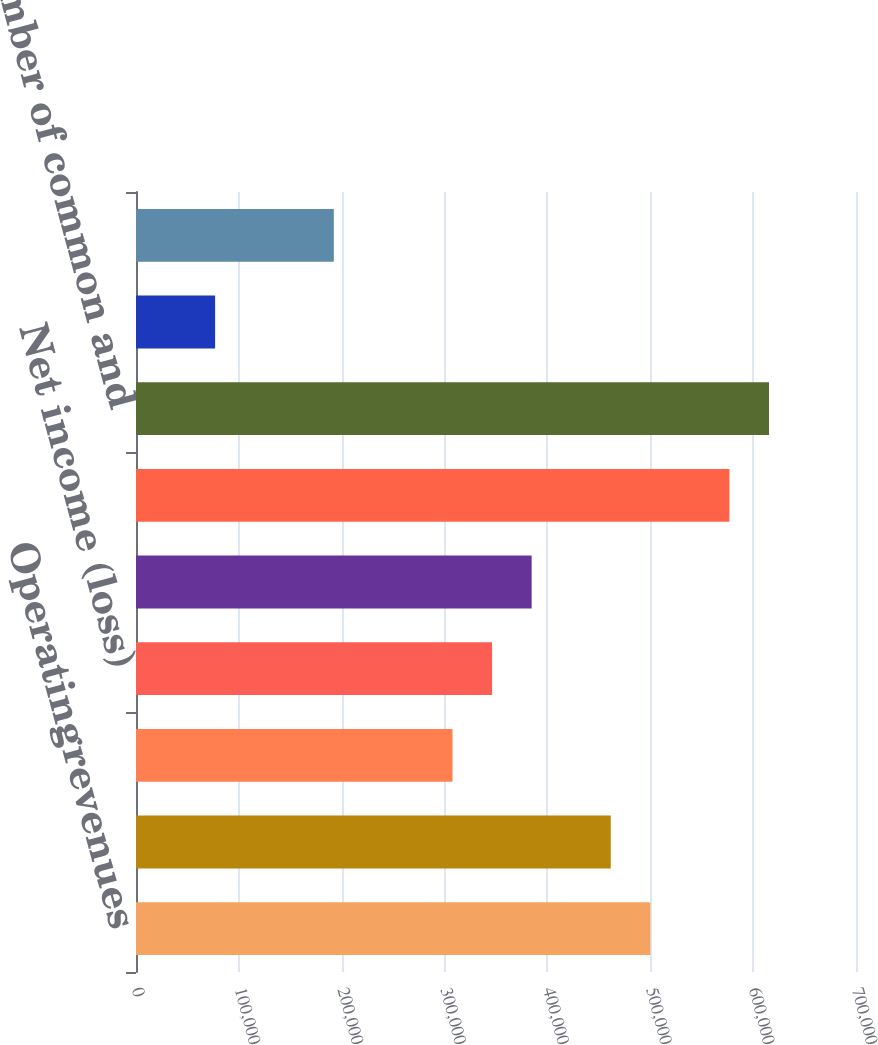<chart> <loc_0><loc_0><loc_500><loc_500><bar_chart><fcel>Operatingrevenues<fcel>Operatingexpenses<fcel>Income from continuing<fcel>Net income (loss)<fcel>Earnings available for common<fcel>Average number of common<fcel>Average number of common and<fcel>Earnings per share from<fcel>Earnings per share-basic<nl><fcel>500040<fcel>461575<fcel>307717<fcel>346182<fcel>384646<fcel>576968<fcel>615433<fcel>76930.1<fcel>192324<nl></chart> 